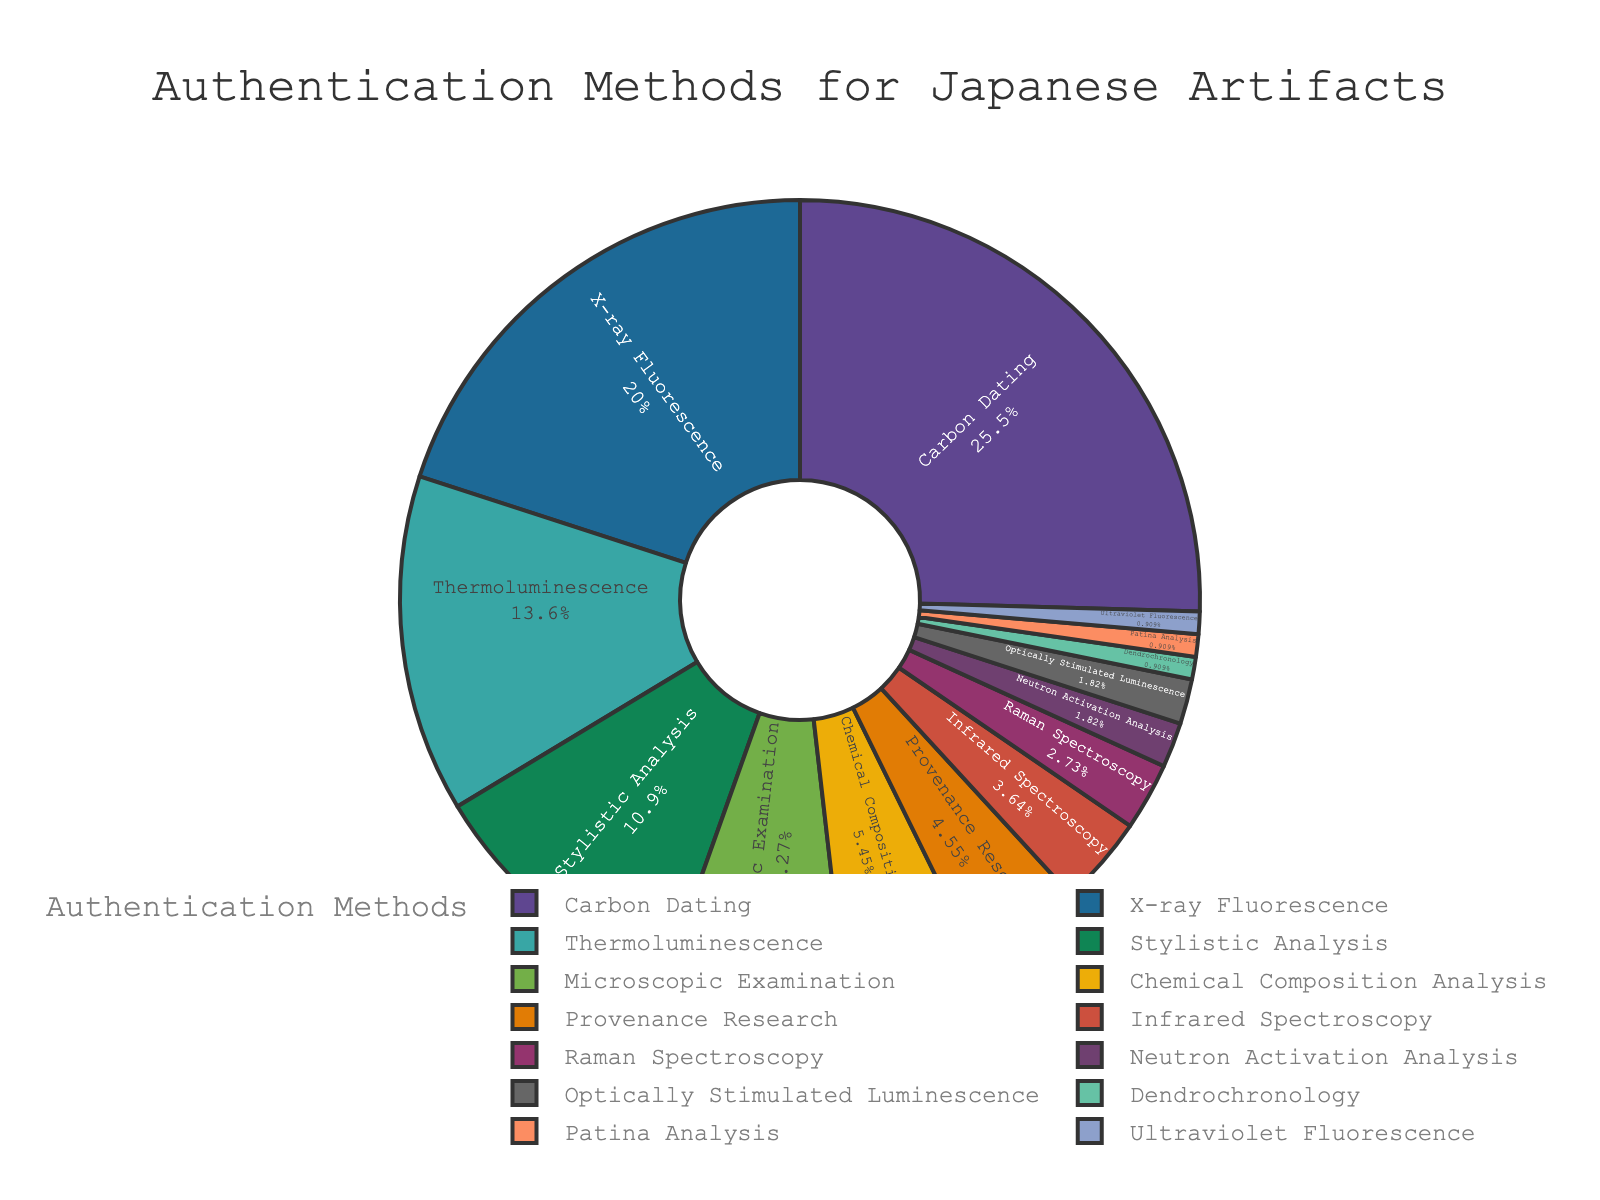what method is used the most for authenticating Japanese artifacts? By examining the pie chart, we can see the segment with the largest percentage value. The largest portion is labeled "Carbon Dating" with 28%.
Answer: Carbon Dating which method is used less frequently, X-ray Fluorescence or Thermoluminescence? Referring to the pie chart, we note the percentage values for each method. X-ray Fluorescence is 22%, while Thermoluminescence is 15%. Since 22% is greater than 15%, Thermoluminescence is used less frequently.
Answer: Thermoluminescence what is the total percentage of methods that utilize spectral analysis techniques (i.e., Infrared Spectroscopy, Raman Spectroscopy, and Ultraviolet Fluorescence)? We identify and sum the percentages for the three spectral analysis methods: Infrared Spectroscopy (4%), Raman Spectroscopy (3%), and Ultraviolet Fluorescence (1%). The total is 4% + 3% + 1% = 8%.
Answer: 8% how much more popular is Carbon Dating compared to Provenance Research? We find the percentage values for Carbon Dating (28%) and Provenance Research (5%). We then calculate the difference: 28% - 5% = 23%.
Answer: 23% which method occupies the smallest portion of the pie chart? Examining the pie chart, the smallest segments are labeled "Dendrochronology," "Patina Analysis," and "Ultraviolet Fluorescence," each with 1%.
Answer: Dendrochronology, Patina Analysis, Ultraviolet Fluorescence how does Stylistic Analysis compare to Microscopic Examination in terms of usage percentage? We refer to the pie chart for the percentages: Stylistic Analysis (12%) and Microscopic Examination (8%). Since 12% is greater than 8%, Stylistic Analysis is used more frequently.
Answer: Stylistic Analysis is used more frequently what is the combined percentage of the methods accounting for more than 20%? We find the methods with percentages above 20%: Carbon Dating (28%) and X-ray Fluorescence (22%). Adding these yields 28% + 22% = 50%.
Answer: 50% if you sum the percentages of Thermoluminescence and Optically Stimulated Luminescence, what do you get? We locate Thermoluminescence (15%) and Optically Stimulated Luminescence (2%) and add these values: 15% + 2% = 17%.
Answer: 17% which verification method ranks third in terms of usage percentage? Sorting the segments of the pie chart by percentage in descending order, we identify Carbon Dating (28%), X-ray Fluorescence (22%), and then Thermoluminescence (15%) as the third highest.
Answer: Thermoluminescence 